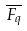Convert formula to latex. <formula><loc_0><loc_0><loc_500><loc_500>\overline { F _ { q } }</formula> 